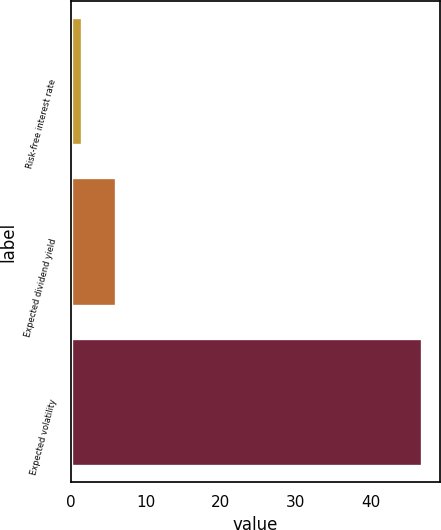Convert chart. <chart><loc_0><loc_0><loc_500><loc_500><bar_chart><fcel>Risk-free interest rate<fcel>Expected dividend yield<fcel>Expected volatility<nl><fcel>1.5<fcel>6.04<fcel>46.9<nl></chart> 